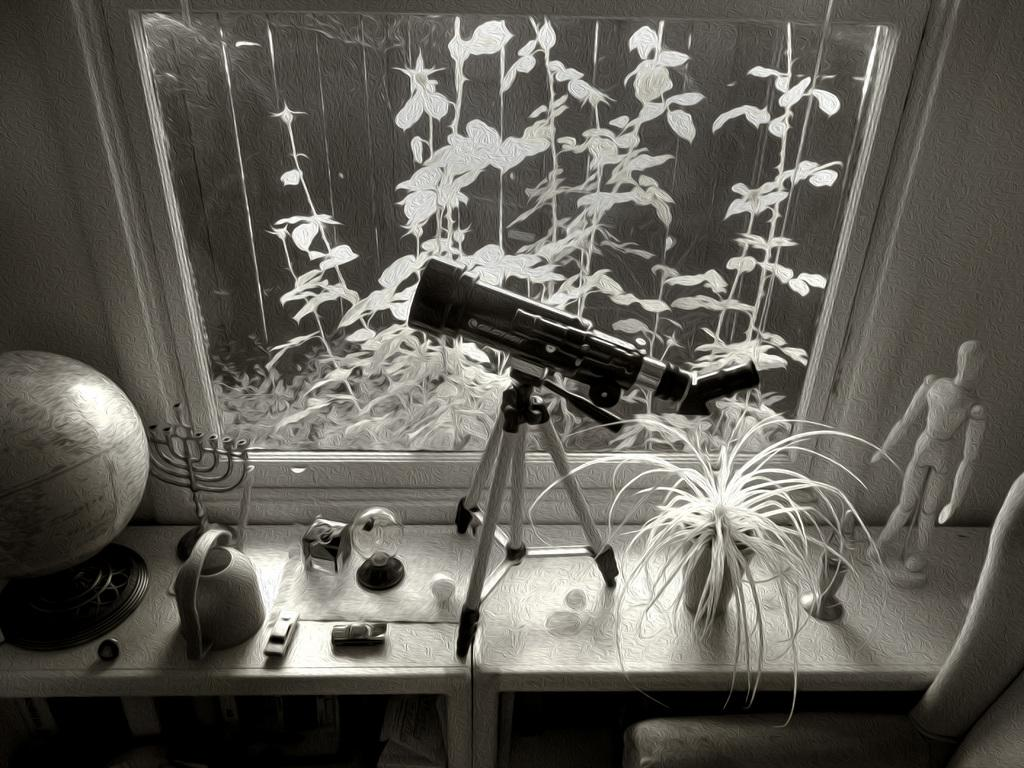What is the main object on the stand in the image? There is a telescope on a stand in the image. What type of living organisms can be seen in the image? There are plants in the image, including a plant in a pot. What is the round object with geographical features in the image? There is a globe in the image. What can be found on the table in the image? There are toys on a table in the image. What type of furniture is present in the image? There is a chair in the image. What type of metal is the yak using to walk in the image? There is no yak present in the image, and therefore no metal or walking activity can be observed. 